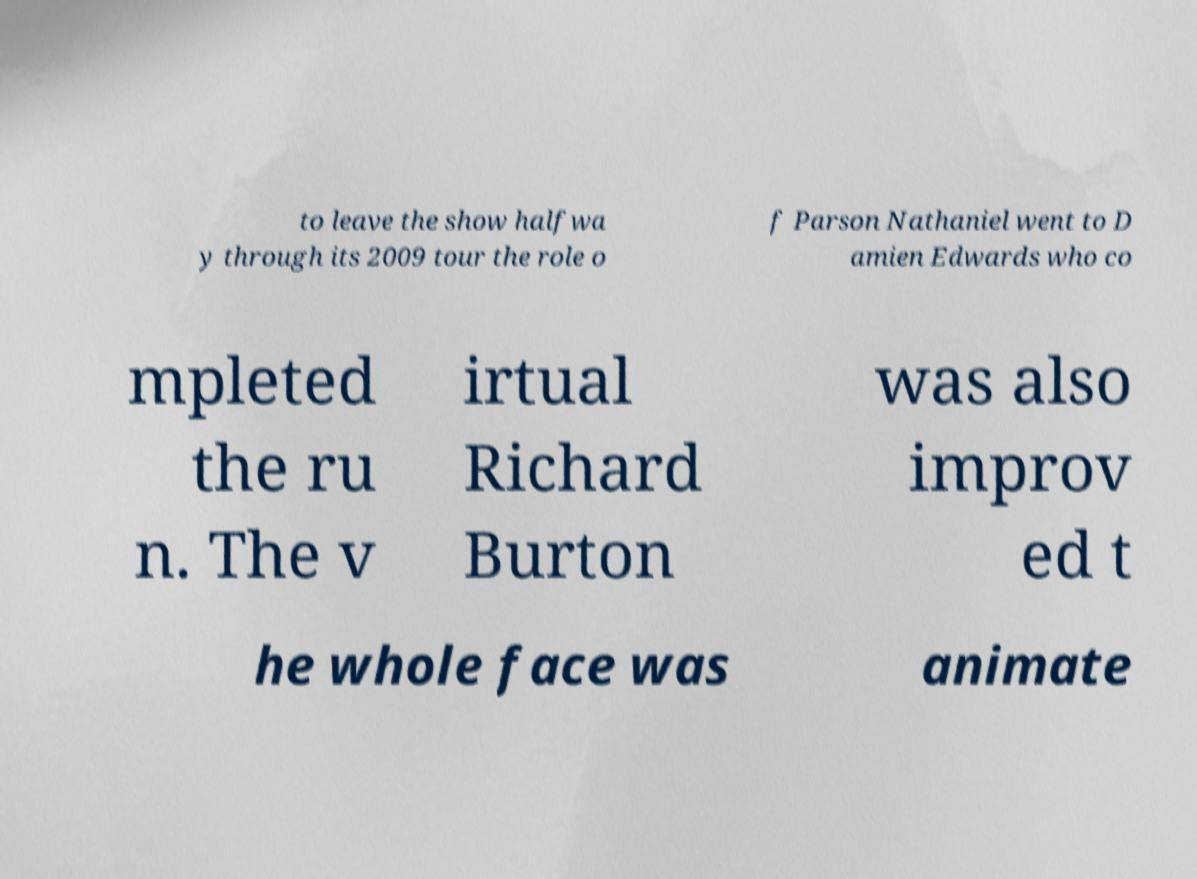For documentation purposes, I need the text within this image transcribed. Could you provide that? to leave the show halfwa y through its 2009 tour the role o f Parson Nathaniel went to D amien Edwards who co mpleted the ru n. The v irtual Richard Burton was also improv ed t he whole face was animate 